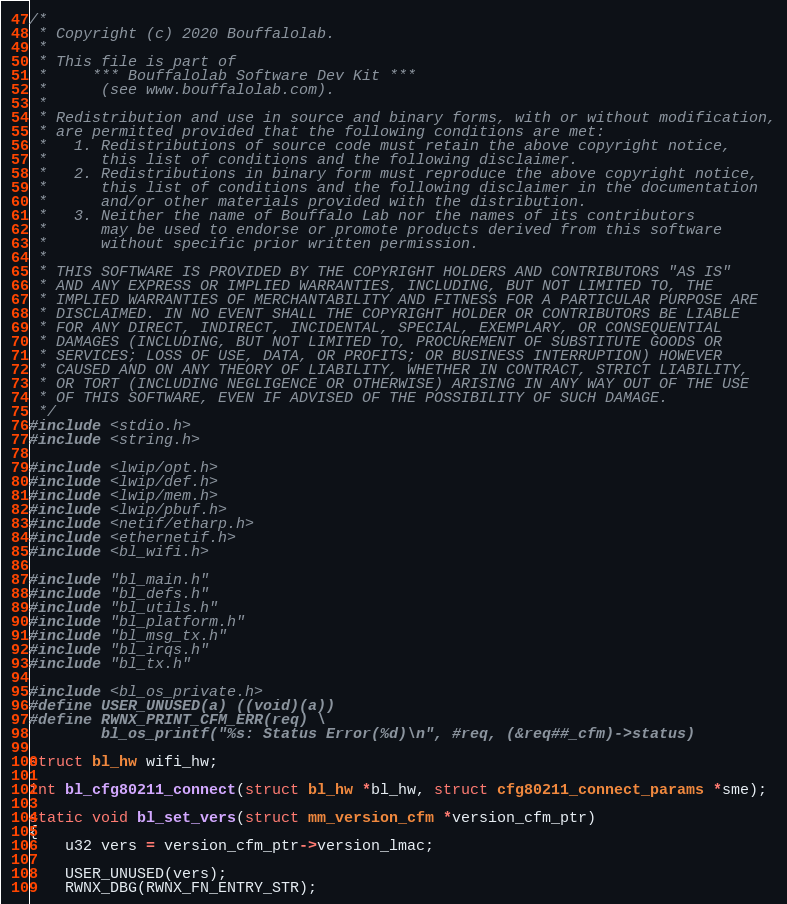Convert code to text. <code><loc_0><loc_0><loc_500><loc_500><_C_>/*
 * Copyright (c) 2020 Bouffalolab.
 *
 * This file is part of
 *     *** Bouffalolab Software Dev Kit ***
 *      (see www.bouffalolab.com).
 *
 * Redistribution and use in source and binary forms, with or without modification,
 * are permitted provided that the following conditions are met:
 *   1. Redistributions of source code must retain the above copyright notice,
 *      this list of conditions and the following disclaimer.
 *   2. Redistributions in binary form must reproduce the above copyright notice,
 *      this list of conditions and the following disclaimer in the documentation
 *      and/or other materials provided with the distribution.
 *   3. Neither the name of Bouffalo Lab nor the names of its contributors
 *      may be used to endorse or promote products derived from this software
 *      without specific prior written permission.
 *
 * THIS SOFTWARE IS PROVIDED BY THE COPYRIGHT HOLDERS AND CONTRIBUTORS "AS IS"
 * AND ANY EXPRESS OR IMPLIED WARRANTIES, INCLUDING, BUT NOT LIMITED TO, THE
 * IMPLIED WARRANTIES OF MERCHANTABILITY AND FITNESS FOR A PARTICULAR PURPOSE ARE
 * DISCLAIMED. IN NO EVENT SHALL THE COPYRIGHT HOLDER OR CONTRIBUTORS BE LIABLE
 * FOR ANY DIRECT, INDIRECT, INCIDENTAL, SPECIAL, EXEMPLARY, OR CONSEQUENTIAL
 * DAMAGES (INCLUDING, BUT NOT LIMITED TO, PROCUREMENT OF SUBSTITUTE GOODS OR
 * SERVICES; LOSS OF USE, DATA, OR PROFITS; OR BUSINESS INTERRUPTION) HOWEVER
 * CAUSED AND ON ANY THEORY OF LIABILITY, WHETHER IN CONTRACT, STRICT LIABILITY,
 * OR TORT (INCLUDING NEGLIGENCE OR OTHERWISE) ARISING IN ANY WAY OUT OF THE USE
 * OF THIS SOFTWARE, EVEN IF ADVISED OF THE POSSIBILITY OF SUCH DAMAGE.
 */
#include <stdio.h>
#include <string.h>

#include <lwip/opt.h>
#include <lwip/def.h>
#include <lwip/mem.h>
#include <lwip/pbuf.h>
#include <netif/etharp.h>
#include <ethernetif.h>
#include <bl_wifi.h>

#include "bl_main.h"
#include "bl_defs.h"
#include "bl_utils.h"
#include "bl_platform.h"
#include "bl_msg_tx.h"
#include "bl_irqs.h"
#include "bl_tx.h"

#include <bl_os_private.h>
#define USER_UNUSED(a) ((void)(a))
#define RWNX_PRINT_CFM_ERR(req) \
        bl_os_printf("%s: Status Error(%d)\n", #req, (&req##_cfm)->status)

struct bl_hw wifi_hw;

int bl_cfg80211_connect(struct bl_hw *bl_hw, struct cfg80211_connect_params *sme);

static void bl_set_vers(struct mm_version_cfm *version_cfm_ptr)
{
    u32 vers = version_cfm_ptr->version_lmac;

    USER_UNUSED(vers);
    RWNX_DBG(RWNX_FN_ENTRY_STR);
</code> 